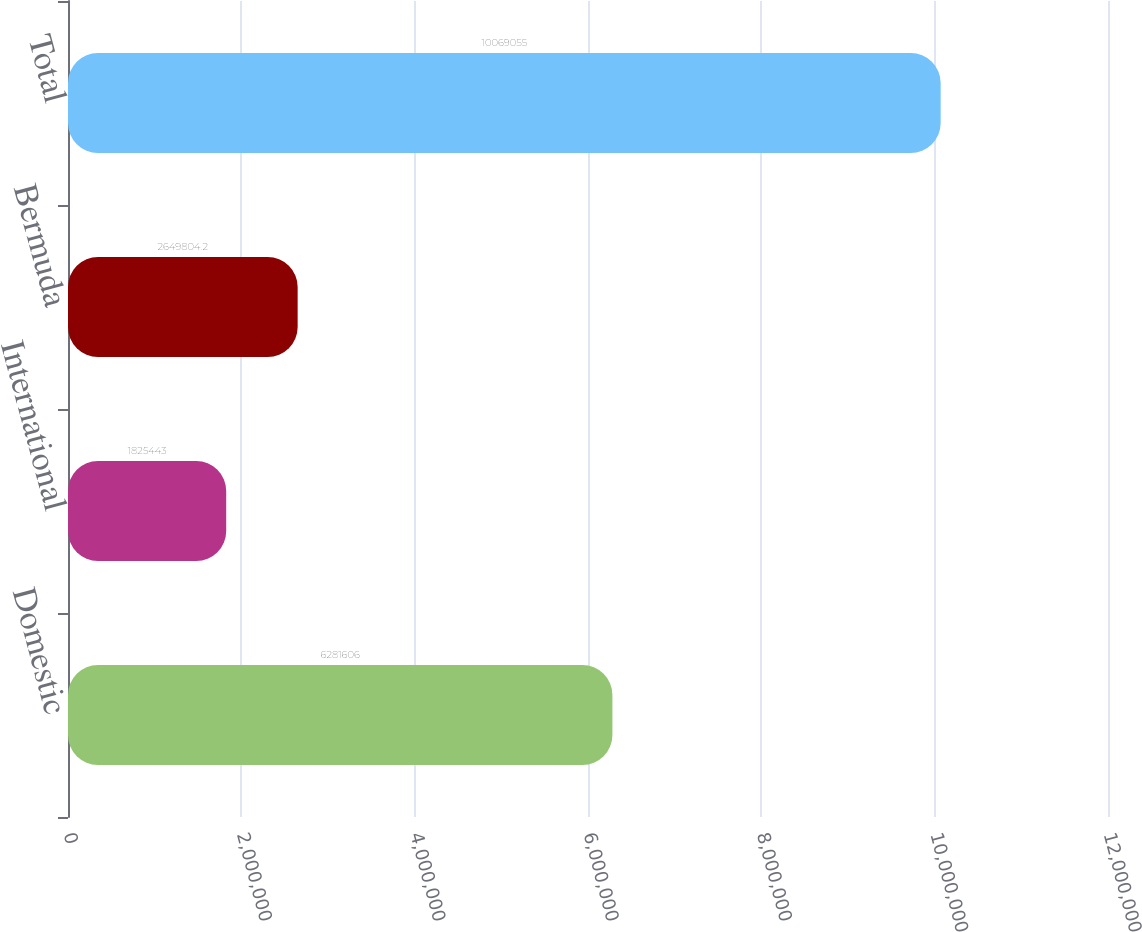Convert chart to OTSL. <chart><loc_0><loc_0><loc_500><loc_500><bar_chart><fcel>Domestic<fcel>International<fcel>Bermuda<fcel>Total<nl><fcel>6.28161e+06<fcel>1.82544e+06<fcel>2.6498e+06<fcel>1.00691e+07<nl></chart> 